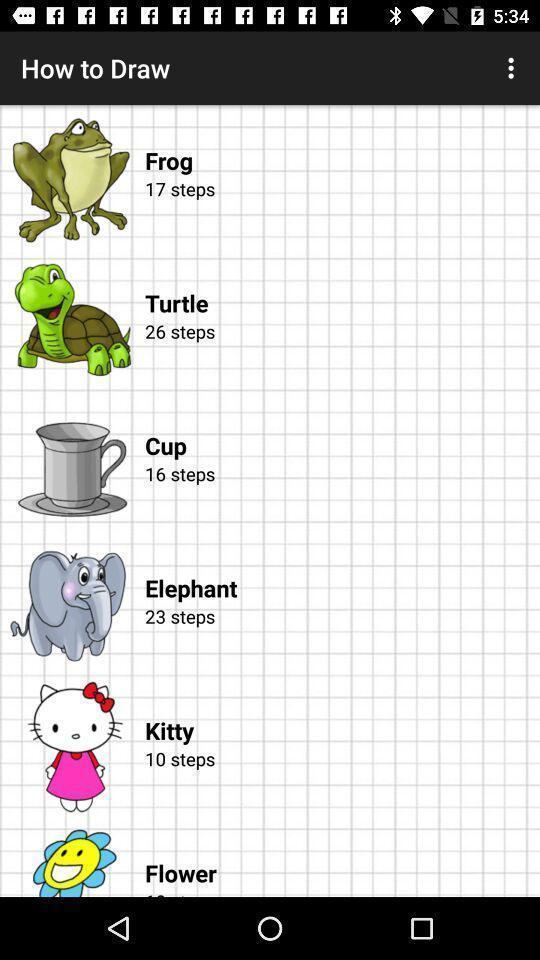Summarize the information in this screenshot. Page displaying information about drawing application. 